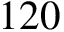Convert formula to latex. <formula><loc_0><loc_0><loc_500><loc_500>1 2 0</formula> 